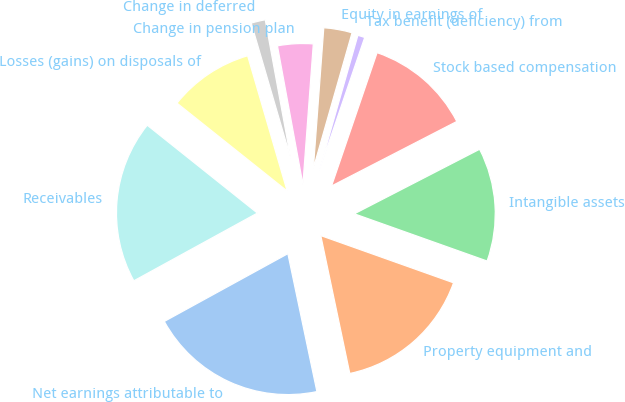Convert chart to OTSL. <chart><loc_0><loc_0><loc_500><loc_500><pie_chart><fcel>Net earnings attributable to<fcel>Property equipment and<fcel>Intangible assets<fcel>Stock based compensation<fcel>Tax benefit (deficiency) from<fcel>Equity in earnings of<fcel>Change in pension plan<fcel>Change in deferred<fcel>Losses (gains) on disposals of<fcel>Receivables<nl><fcel>20.32%<fcel>16.26%<fcel>13.01%<fcel>12.19%<fcel>0.81%<fcel>3.25%<fcel>4.07%<fcel>1.63%<fcel>9.76%<fcel>18.7%<nl></chart> 